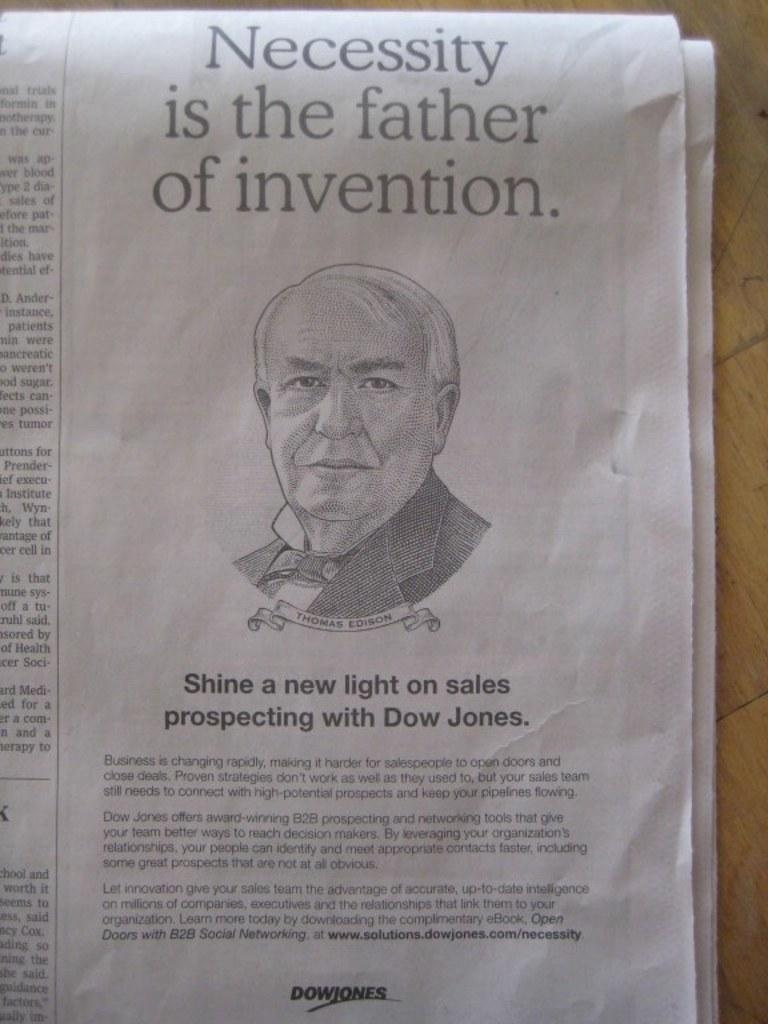What can be seen in the image that people read for news and information? There is a newspaper in the image. Whose face is visible in the image? A person's face is visible in the image. What is present at the top and bottom of the image? There is text at the top and bottom of the image. How many oranges are being used as a lumber substitute in the image? There are no oranges or lumber present in the image. What thought is the person having in the image? The image does not show the person's thoughts, only their face. 